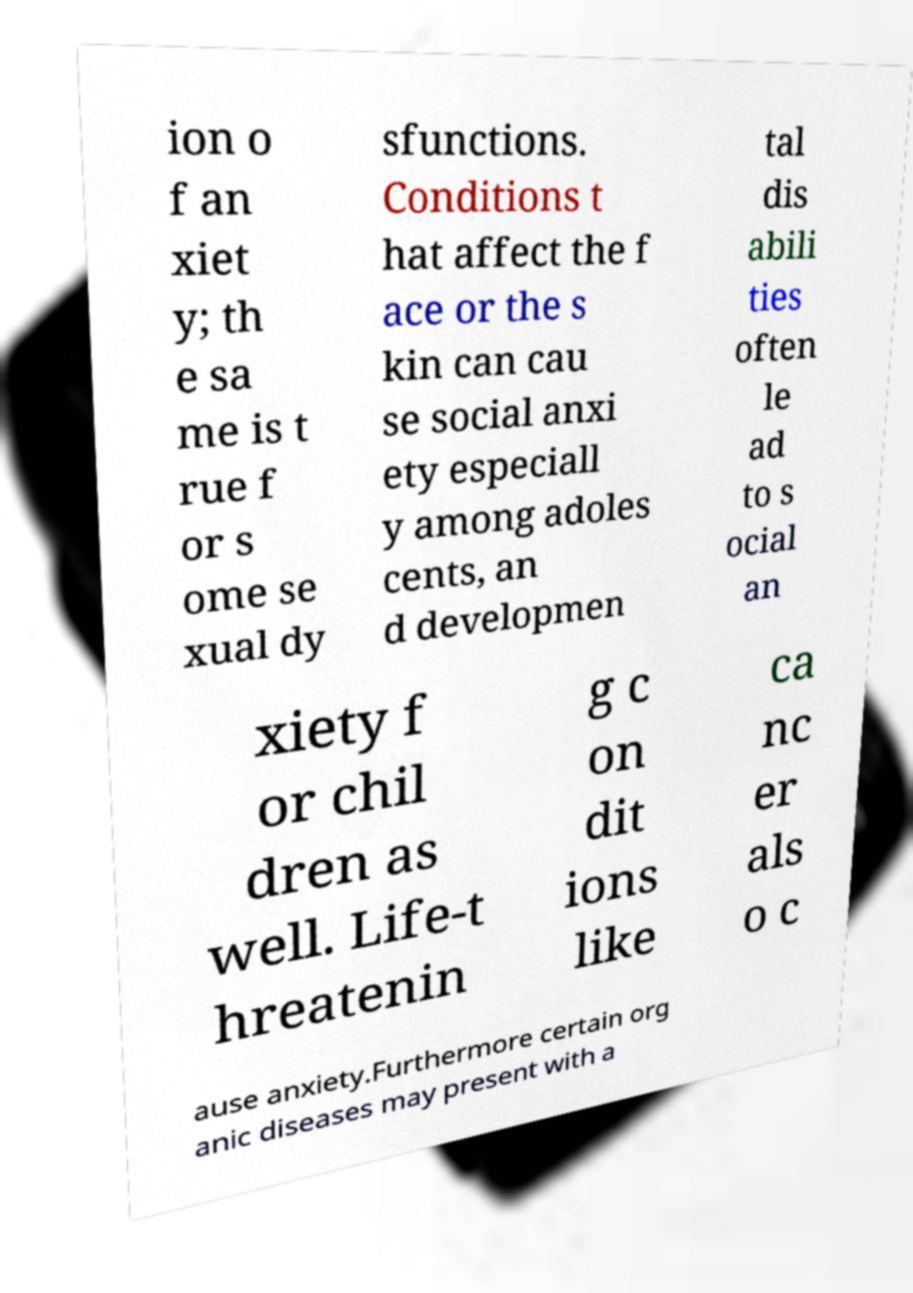Can you accurately transcribe the text from the provided image for me? ion o f an xiet y; th e sa me is t rue f or s ome se xual dy sfunctions. Conditions t hat affect the f ace or the s kin can cau se social anxi ety especiall y among adoles cents, an d developmen tal dis abili ties often le ad to s ocial an xiety f or chil dren as well. Life-t hreatenin g c on dit ions like ca nc er als o c ause anxiety.Furthermore certain org anic diseases may present with a 